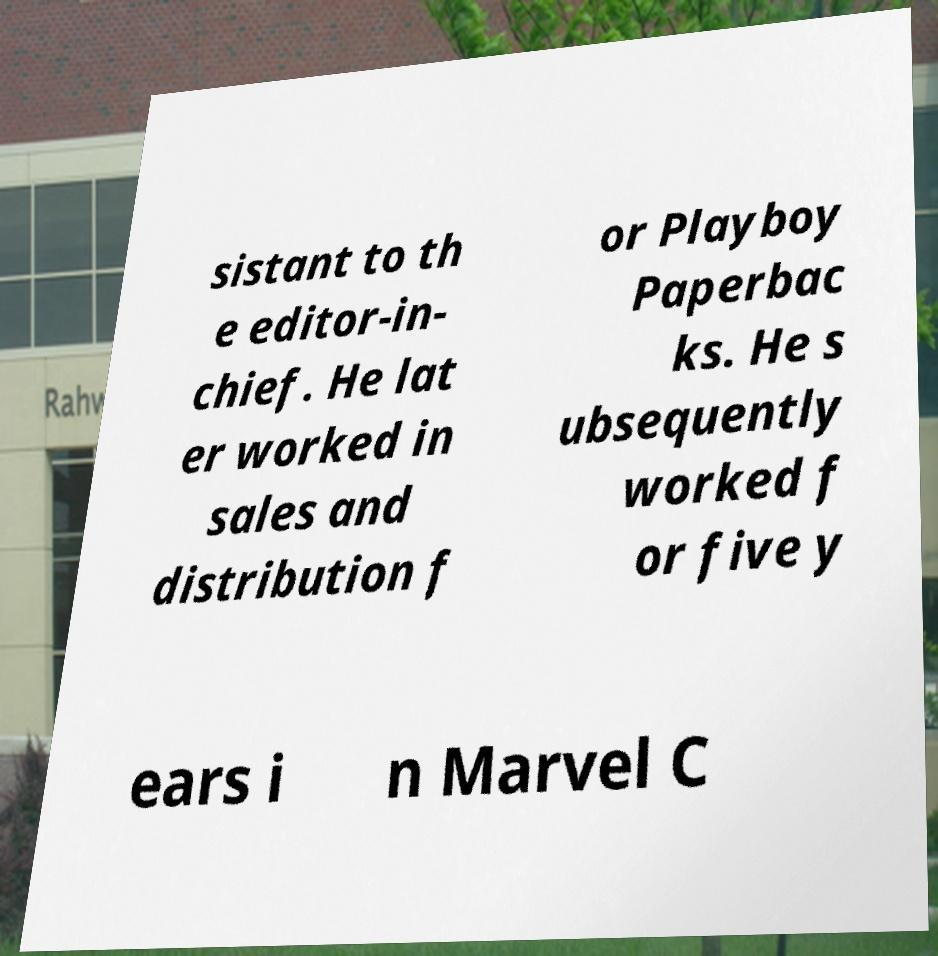For documentation purposes, I need the text within this image transcribed. Could you provide that? sistant to th e editor-in- chief. He lat er worked in sales and distribution f or Playboy Paperbac ks. He s ubsequently worked f or five y ears i n Marvel C 